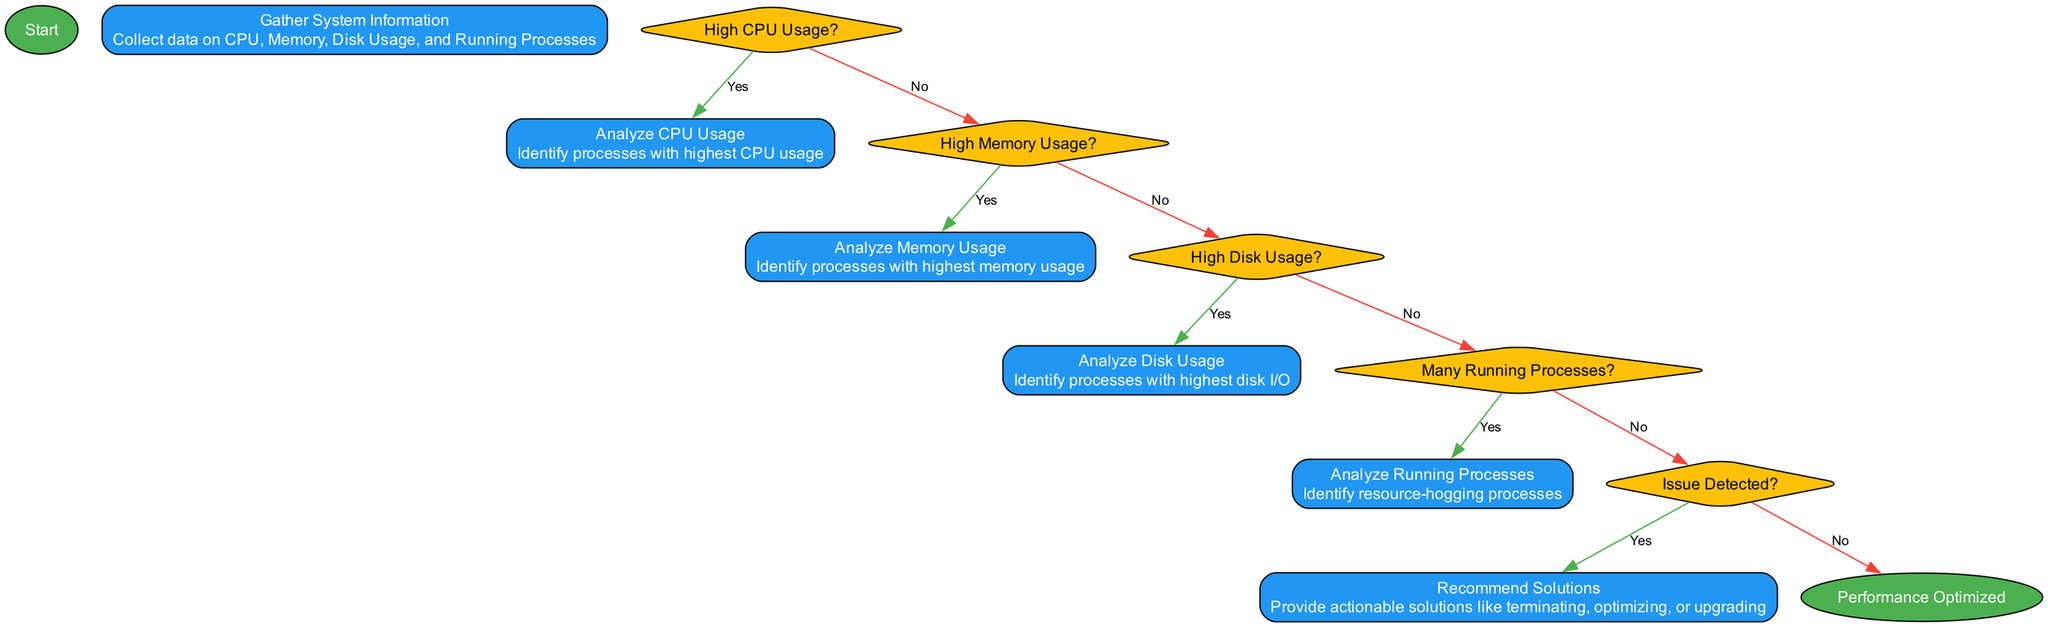What is the first step in the flowchart? The first step is "Gather System Information," which is the only process that comes after the "Start" node.
Answer: Gather System Information How many decision nodes are there in the flowchart? There are four decision nodes: "High CPU Usage?", "High Memory Usage?", "High Disk Usage?", and "Many Running Processes?".
Answer: Four What action follows a positive answer to "High CPU Usage?" A positive answer leads to "Analyze CPU Usage," which is the process for identifying high CPU usage processes.
Answer: Analyze CPU Usage What is the final outcome of the flowchart? The final outcome, after optimizing performance, is indicated by the "Performance Optimized" node.
Answer: Performance Optimized If there is high disk usage, what process is analyzed next? The next process analyzed would be "Analyze Disk Usage," as indicated by the flow path from the "High Disk Usage?" decision.
Answer: Analyze Disk Usage After the analysis, what does a "Yes" answer to "Issue Detected?" lead to? A "Yes" answer leads to "Recommend Solutions," indicating the flowchart will provide solutions for the detected issues.
Answer: Recommend Solutions How many processes are included in the flowchart? There are five processes: "Gather System Information," "Analyze CPU Usage," "Analyze Memory Usage," "Analyze Disk Usage," and "Analyze Running Processes."
Answer: Five What is the action taken after all analyses if no issues are detected? If no issues are detected, the flowchart concludes with "Performance Optimized," suggesting that the computer is operating efficiently.
Answer: Performance Optimized 